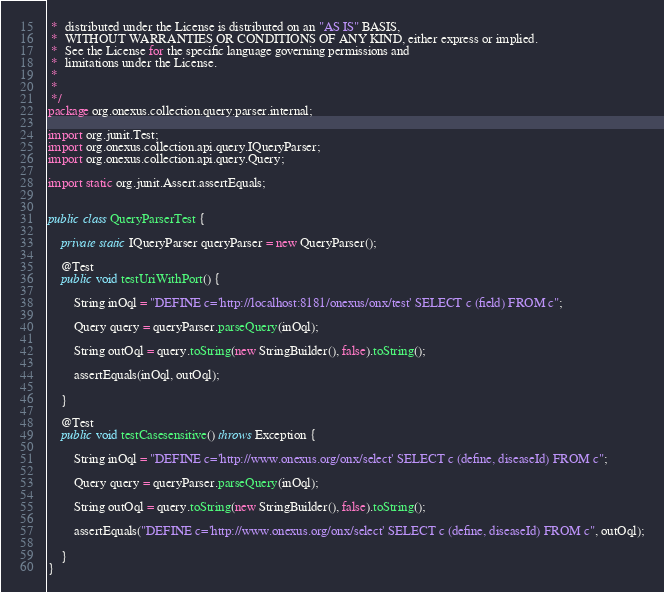Convert code to text. <code><loc_0><loc_0><loc_500><loc_500><_Java_> *  distributed under the License is distributed on an "AS IS" BASIS,
 *  WITHOUT WARRANTIES OR CONDITIONS OF ANY KIND, either express or implied.
 *  See the License for the specific language governing permissions and
 *  limitations under the License.
 *
 *
 */
package org.onexus.collection.query.parser.internal;

import org.junit.Test;
import org.onexus.collection.api.query.IQueryParser;
import org.onexus.collection.api.query.Query;

import static org.junit.Assert.assertEquals;


public class QueryParserTest {

    private static IQueryParser queryParser = new QueryParser();

    @Test
    public void testUriWithPort() {

        String inOql = "DEFINE c='http://localhost:8181/onexus/onx/test' SELECT c (field) FROM c";

        Query query = queryParser.parseQuery(inOql);

        String outOql = query.toString(new StringBuilder(), false).toString();

        assertEquals(inOql, outOql);

    }

    @Test
    public void testCasesensitive() throws Exception {

        String inOql = "DEFINE c='http://www.onexus.org/onx/select' SELECT c (define, diseaseId) FROM c";

        Query query = queryParser.parseQuery(inOql);

        String outOql = query.toString(new StringBuilder(), false).toString();

        assertEquals("DEFINE c='http://www.onexus.org/onx/select' SELECT c (define, diseaseId) FROM c", outOql);

    }
}

</code> 